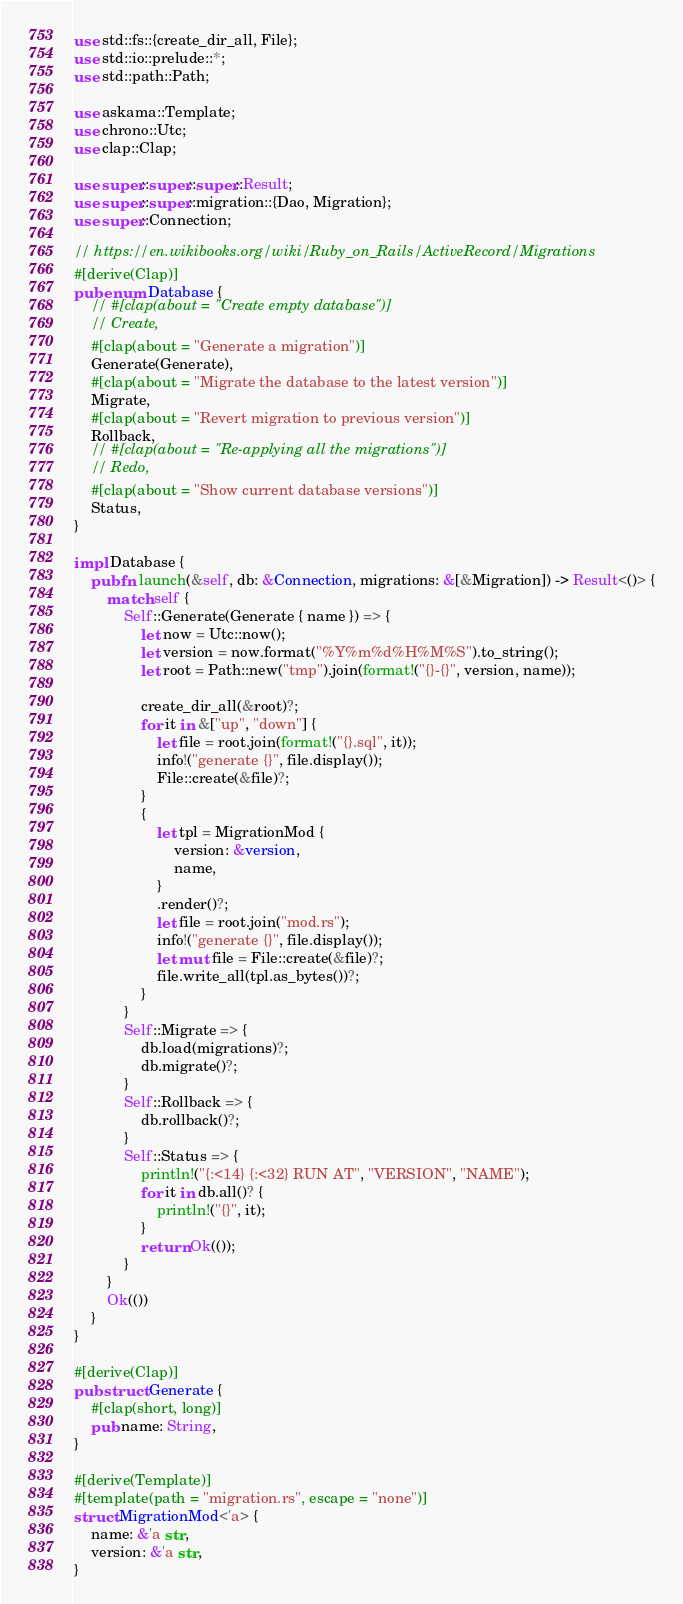Convert code to text. <code><loc_0><loc_0><loc_500><loc_500><_Rust_>use std::fs::{create_dir_all, File};
use std::io::prelude::*;
use std::path::Path;

use askama::Template;
use chrono::Utc;
use clap::Clap;

use super::super::super::Result;
use super::super::migration::{Dao, Migration};
use super::Connection;

// https://en.wikibooks.org/wiki/Ruby_on_Rails/ActiveRecord/Migrations
#[derive(Clap)]
pub enum Database {
    // #[clap(about = "Create empty database")]
    // Create,
    #[clap(about = "Generate a migration")]
    Generate(Generate),
    #[clap(about = "Migrate the database to the latest version")]
    Migrate,
    #[clap(about = "Revert migration to previous version")]
    Rollback,
    // #[clap(about = "Re-applying all the migrations")]
    // Redo,
    #[clap(about = "Show current database versions")]
    Status,
}

impl Database {
    pub fn launch(&self, db: &Connection, migrations: &[&Migration]) -> Result<()> {
        match self {
            Self::Generate(Generate { name }) => {
                let now = Utc::now();
                let version = now.format("%Y%m%d%H%M%S").to_string();
                let root = Path::new("tmp").join(format!("{}-{}", version, name));

                create_dir_all(&root)?;
                for it in &["up", "down"] {
                    let file = root.join(format!("{}.sql", it));
                    info!("generate {}", file.display());
                    File::create(&file)?;
                }
                {
                    let tpl = MigrationMod {
                        version: &version,
                        name,
                    }
                    .render()?;
                    let file = root.join("mod.rs");
                    info!("generate {}", file.display());
                    let mut file = File::create(&file)?;
                    file.write_all(tpl.as_bytes())?;
                }
            }
            Self::Migrate => {
                db.load(migrations)?;
                db.migrate()?;
            }
            Self::Rollback => {
                db.rollback()?;
            }
            Self::Status => {
                println!("{:<14} {:<32} RUN AT", "VERSION", "NAME");
                for it in db.all()? {
                    println!("{}", it);
                }
                return Ok(());
            }
        }
        Ok(())
    }
}

#[derive(Clap)]
pub struct Generate {
    #[clap(short, long)]
    pub name: String,
}

#[derive(Template)]
#[template(path = "migration.rs", escape = "none")]
struct MigrationMod<'a> {
    name: &'a str,
    version: &'a str,
}
</code> 